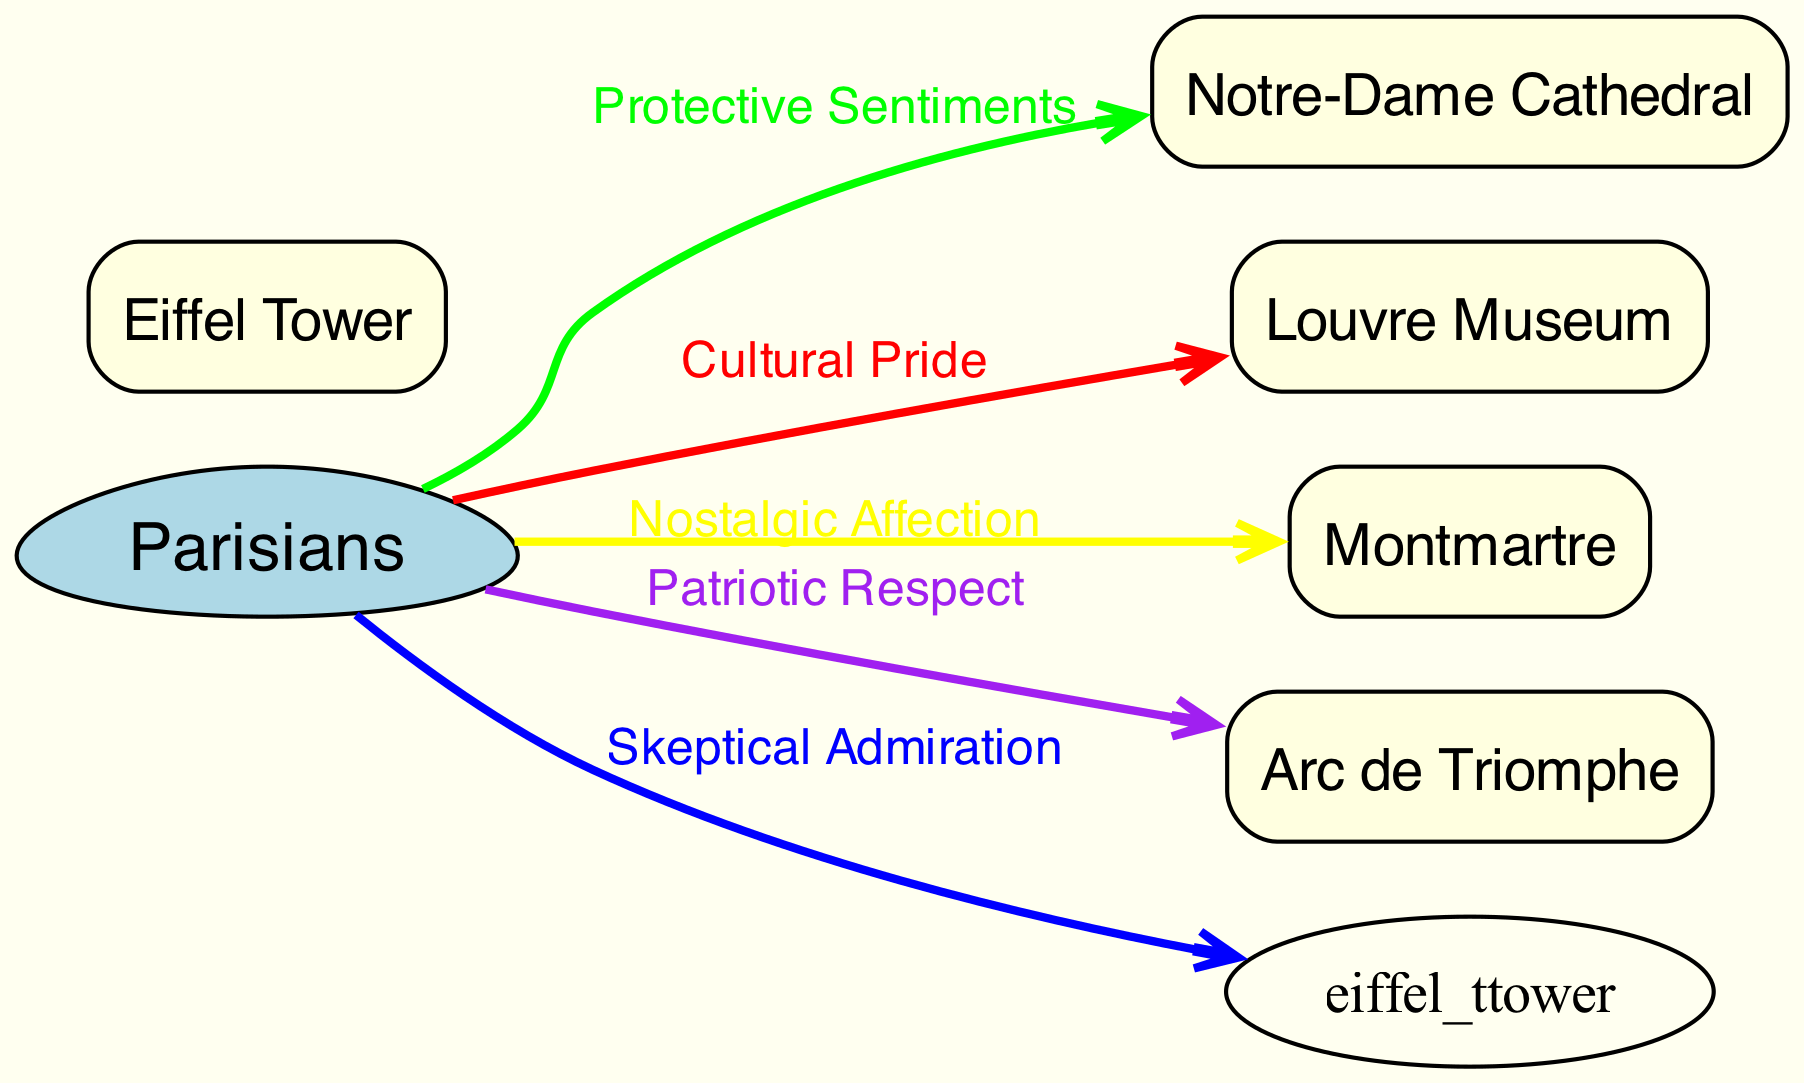What's the total number of nodes in the diagram? The diagram contains six nodes: one for "Parisians" and one for each of the five landmarks (Eiffel Tower, Notre-Dame Cathedral, Louvre Museum, Montmartre, Arc de Triomphe). Counting these gives a total of six nodes.
Answer: 6 Which landmark is associated with "Skeptical Admiration"? The edge that connects "Parisians" to "Eiffel Tower" is labeled "Skeptical Admiration". Therefore, the landmark associated with this sentiment is the Eiffel Tower.
Answer: Eiffel Tower What sentiment is expressed towards Montmartre? The edge connecting "Parisians" to "Montmartre" is labeled "Nostalgic Affection". Thus, the sentiment expressed towards Montmartre is Nostalgic Affection.
Answer: Nostalgic Affection How many different sentiments are portrayed in the diagram? There are five sentiments indicated by the edges: Skeptical Admiration, Protective Sentiments, Cultural Pride, Nostalgic Affection, and Patriotic Respect. Therefore, there are five different sentiments portrayed.
Answer: 5 What color represents Patriotic Respect in the diagram? The edge labeled "Patriotic Respect" connecting "Parisians" to "Arc de Triomphe" is colored purple, which represents this sentiment.
Answer: Purple Which landmark has a protective sentiment associated with it? The edge leading from "Parisians" to "Notre-Dame Cathedral" is labeled "Protective Sentiments", indicating that this landmark has a protective sentiment associated with it.
Answer: Notre-Dame Cathedral Which sentiment connects "Parisians" to the Louvre Museum? The edge linking "Parisians" to the Louvre Museum is labeled "Cultural Pride", which signifies the sentiment connected to this landmark.
Answer: Cultural Pride What is the relationship between the Parisians and the Arc de Triomphe? The edge from "Parisians" to "Arc de Triomphe" indicates a sentiment of "Patriotic Respect". This defines the relationship between Parisians and this landmark.
Answer: Patriotic Respect 